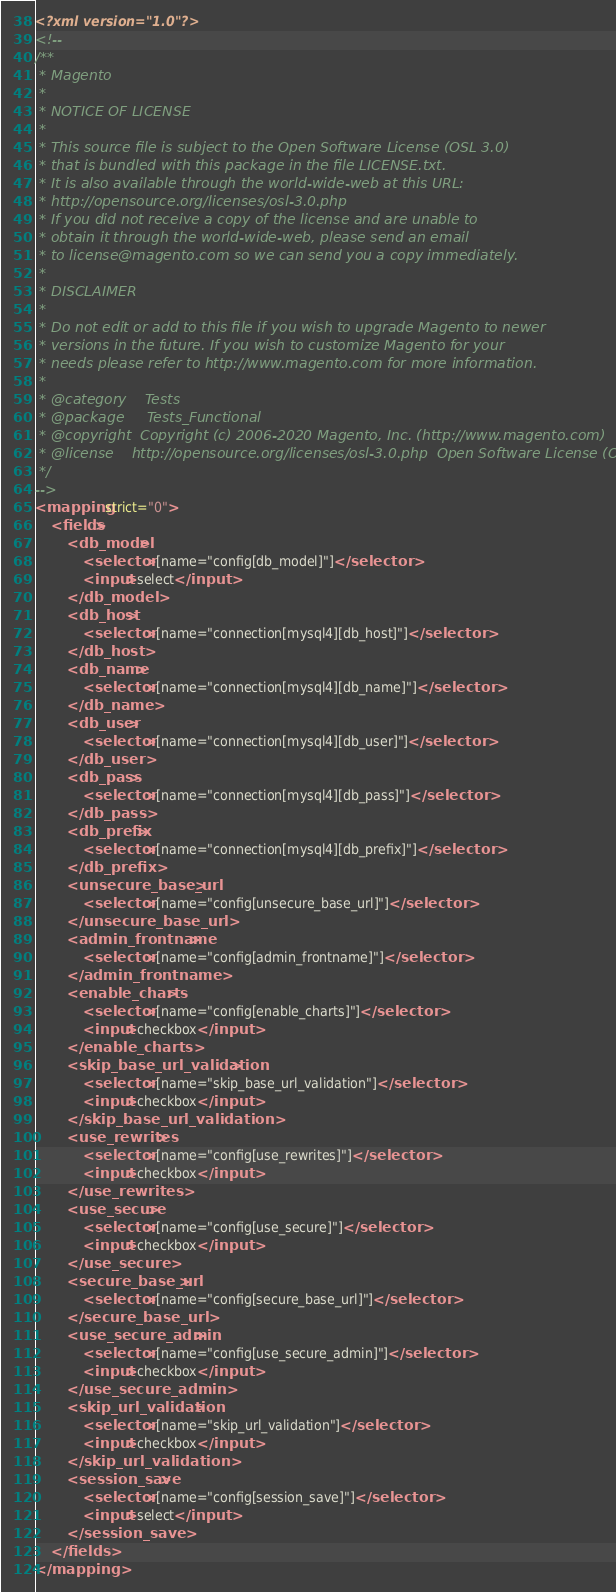Convert code to text. <code><loc_0><loc_0><loc_500><loc_500><_XML_><?xml version="1.0"?>
<!--
/**
 * Magento
 *
 * NOTICE OF LICENSE
 *
 * This source file is subject to the Open Software License (OSL 3.0)
 * that is bundled with this package in the file LICENSE.txt.
 * It is also available through the world-wide-web at this URL:
 * http://opensource.org/licenses/osl-3.0.php
 * If you did not receive a copy of the license and are unable to
 * obtain it through the world-wide-web, please send an email
 * to license@magento.com so we can send you a copy immediately.
 *
 * DISCLAIMER
 *
 * Do not edit or add to this file if you wish to upgrade Magento to newer
 * versions in the future. If you wish to customize Magento for your
 * needs please refer to http://www.magento.com for more information.
 *
 * @category    Tests
 * @package     Tests_Functional
 * @copyright  Copyright (c) 2006-2020 Magento, Inc. (http://www.magento.com)
 * @license    http://opensource.org/licenses/osl-3.0.php  Open Software License (OSL 3.0)
 */
-->
<mapping strict="0">
    <fields>
        <db_model>
            <selector>[name="config[db_model]"]</selector>
            <input>select</input>
        </db_model>
        <db_host>
            <selector>[name="connection[mysql4][db_host]"]</selector>
        </db_host>
        <db_name>
            <selector>[name="connection[mysql4][db_name]"]</selector>
        </db_name>
        <db_user>
            <selector>[name="connection[mysql4][db_user]"]</selector>
        </db_user>
        <db_pass>
            <selector>[name="connection[mysql4][db_pass]"]</selector>
        </db_pass>
        <db_prefix>
            <selector>[name="connection[mysql4][db_prefix]"]</selector>
        </db_prefix>
        <unsecure_base_url>
            <selector>[name="config[unsecure_base_url]"]</selector>
        </unsecure_base_url>
        <admin_frontname>
            <selector>[name="config[admin_frontname]"]</selector>
        </admin_frontname>
        <enable_charts>
            <selector>[name="config[enable_charts]"]</selector>
            <input>checkbox</input>
        </enable_charts>
        <skip_base_url_validation>
            <selector>[name="skip_base_url_validation"]</selector>
            <input>checkbox</input>
        </skip_base_url_validation>
        <use_rewrites>
            <selector>[name="config[use_rewrites]"]</selector>
            <input>checkbox</input>
        </use_rewrites>
        <use_secure>
            <selector>[name="config[use_secure]"]</selector>
            <input>checkbox</input>
        </use_secure>
        <secure_base_url>
            <selector>[name="config[secure_base_url]"]</selector>
        </secure_base_url>
        <use_secure_admin>
            <selector>[name="config[use_secure_admin]"]</selector>
            <input>checkbox</input>
        </use_secure_admin>
        <skip_url_validation>
            <selector>[name="skip_url_validation"]</selector>
            <input>checkbox</input>
        </skip_url_validation>
        <session_save>
            <selector>[name="config[session_save]"]</selector>
            <input>select</input>
        </session_save>
    </fields>
</mapping>
</code> 